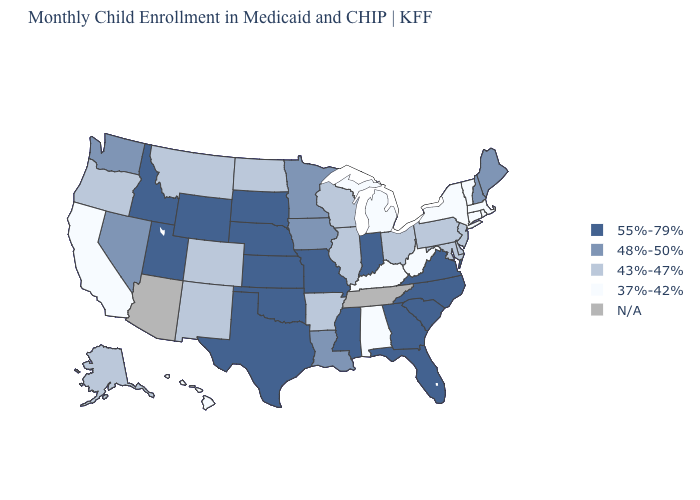What is the value of Arizona?
Keep it brief. N/A. What is the value of Alaska?
Keep it brief. 43%-47%. What is the value of Connecticut?
Quick response, please. 37%-42%. Name the states that have a value in the range 55%-79%?
Be succinct. Florida, Georgia, Idaho, Indiana, Kansas, Mississippi, Missouri, Nebraska, North Carolina, Oklahoma, South Carolina, South Dakota, Texas, Utah, Virginia, Wyoming. Name the states that have a value in the range 55%-79%?
Be succinct. Florida, Georgia, Idaho, Indiana, Kansas, Mississippi, Missouri, Nebraska, North Carolina, Oklahoma, South Carolina, South Dakota, Texas, Utah, Virginia, Wyoming. Among the states that border Utah , does Colorado have the highest value?
Give a very brief answer. No. How many symbols are there in the legend?
Keep it brief. 5. Name the states that have a value in the range N/A?
Keep it brief. Arizona, Tennessee. Name the states that have a value in the range 48%-50%?
Keep it brief. Iowa, Louisiana, Maine, Minnesota, Nevada, New Hampshire, Washington. What is the value of Louisiana?
Give a very brief answer. 48%-50%. Name the states that have a value in the range 37%-42%?
Concise answer only. Alabama, California, Connecticut, Hawaii, Kentucky, Massachusetts, Michigan, New York, Rhode Island, Vermont, West Virginia. What is the highest value in states that border South Carolina?
Give a very brief answer. 55%-79%. Among the states that border New Jersey , does Pennsylvania have the highest value?
Write a very short answer. Yes. What is the value of Maryland?
Concise answer only. 43%-47%. Is the legend a continuous bar?
Write a very short answer. No. 